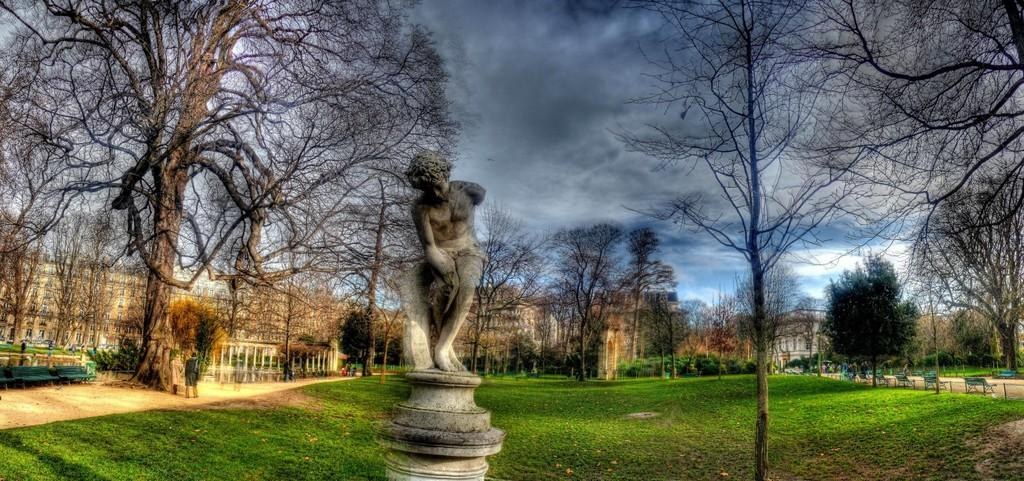What type of structures can be seen in the image? There are buildings in the image. What type of seating is available in the image? There are benches in the image. What are the persons in the image doing? There are persons walking on a walking path in the image. What type of vegetation is present in the image? There are trees in the image. What type of artwork is present in the image? There is a statue in the image. What is the statue standing on in the image? There is a pedestal in the image. What type of debris can be seen on the ground in the image? There are shredded leaves on the ground in the image. What is visible in the sky in the image? The sky is visible in the image, and there are clouds in the sky. What type of rhythm can be heard coming from the statue in the image? There is no indication in the image that the statue is producing any rhythm or sound. What type of pancake is being served on the pedestal in the image? There is no pancake present in the image; the pedestal is supporting a statue. How many coughs can be heard from the persons walking on the walking path in the image? There is no indication in the image that any of the persons are coughing. 